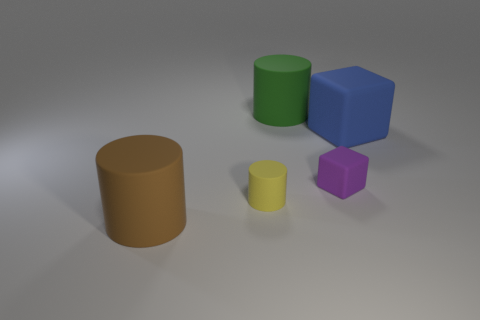There is a big cylinder that is on the left side of the big cylinder that is behind the brown object; what is it made of?
Your answer should be very brief. Rubber. What number of yellow rubber things have the same shape as the brown thing?
Your answer should be compact. 1. What shape is the tiny yellow rubber thing?
Your response must be concise. Cylinder. Is the number of small yellow rubber objects less than the number of large matte spheres?
Provide a succinct answer. No. Is there anything else that is the same size as the blue thing?
Make the answer very short. Yes. What material is the brown object that is the same shape as the green thing?
Offer a very short reply. Rubber. Is the number of shiny objects greater than the number of yellow rubber cylinders?
Keep it short and to the point. No. What number of other objects are the same color as the small matte cylinder?
Offer a terse response. 0. Is the material of the green thing the same as the large cylinder that is in front of the green matte cylinder?
Make the answer very short. Yes. What number of small matte things are to the right of the big rubber cylinder that is behind the large matte cylinder that is in front of the large blue thing?
Offer a terse response. 1. 